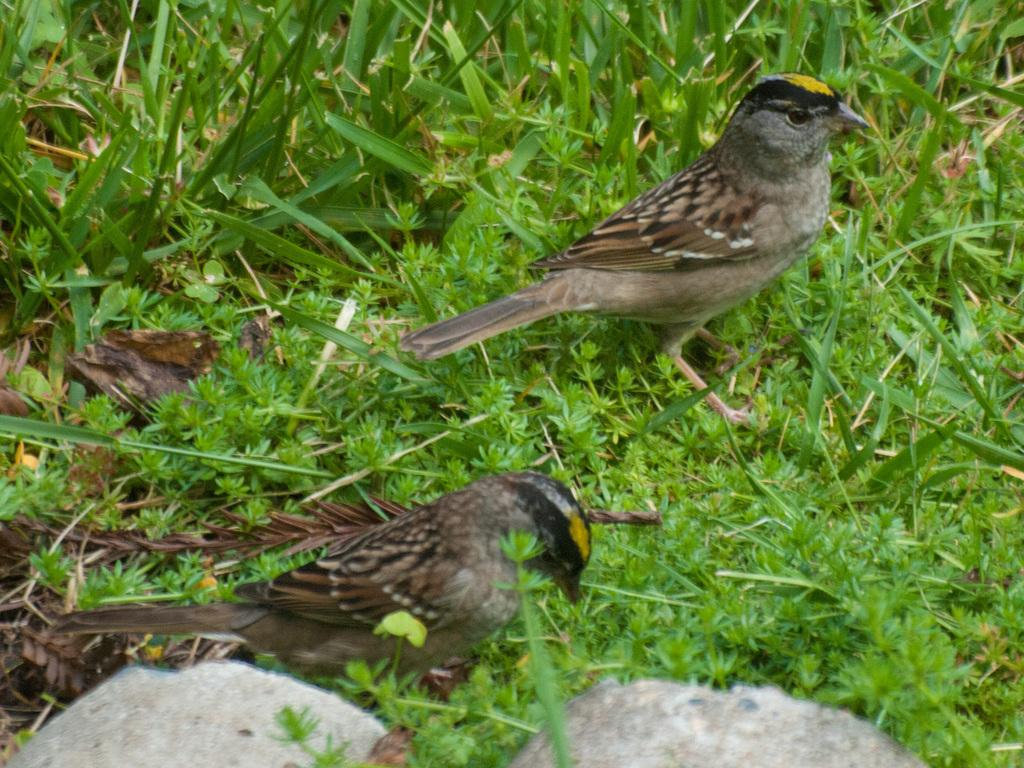How many birds can be seen in the image? There are two birds in the image. Where are the birds located? The birds are on a path. What can be seen behind the birds? There are plants visible behind the birds. What record does the grandmother play for the birds in the image? There is no grandmother or record present in the image; it only features two birds on a path with plants in the background. 